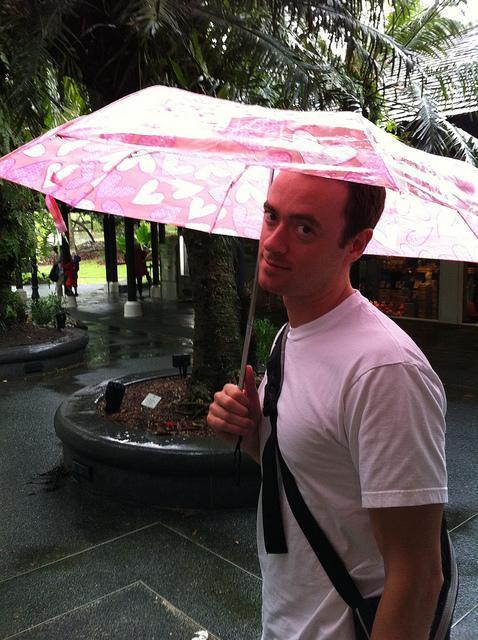How many zebras are in the picture?
Give a very brief answer. 0. 